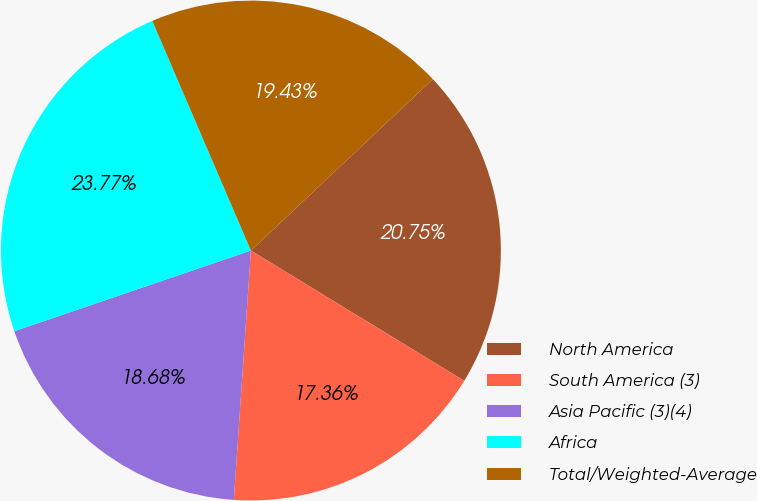<chart> <loc_0><loc_0><loc_500><loc_500><pie_chart><fcel>North America<fcel>South America (3)<fcel>Asia Pacific (3)(4)<fcel>Africa<fcel>Total/Weighted-Average<nl><fcel>20.75%<fcel>17.36%<fcel>18.68%<fcel>23.77%<fcel>19.43%<nl></chart> 